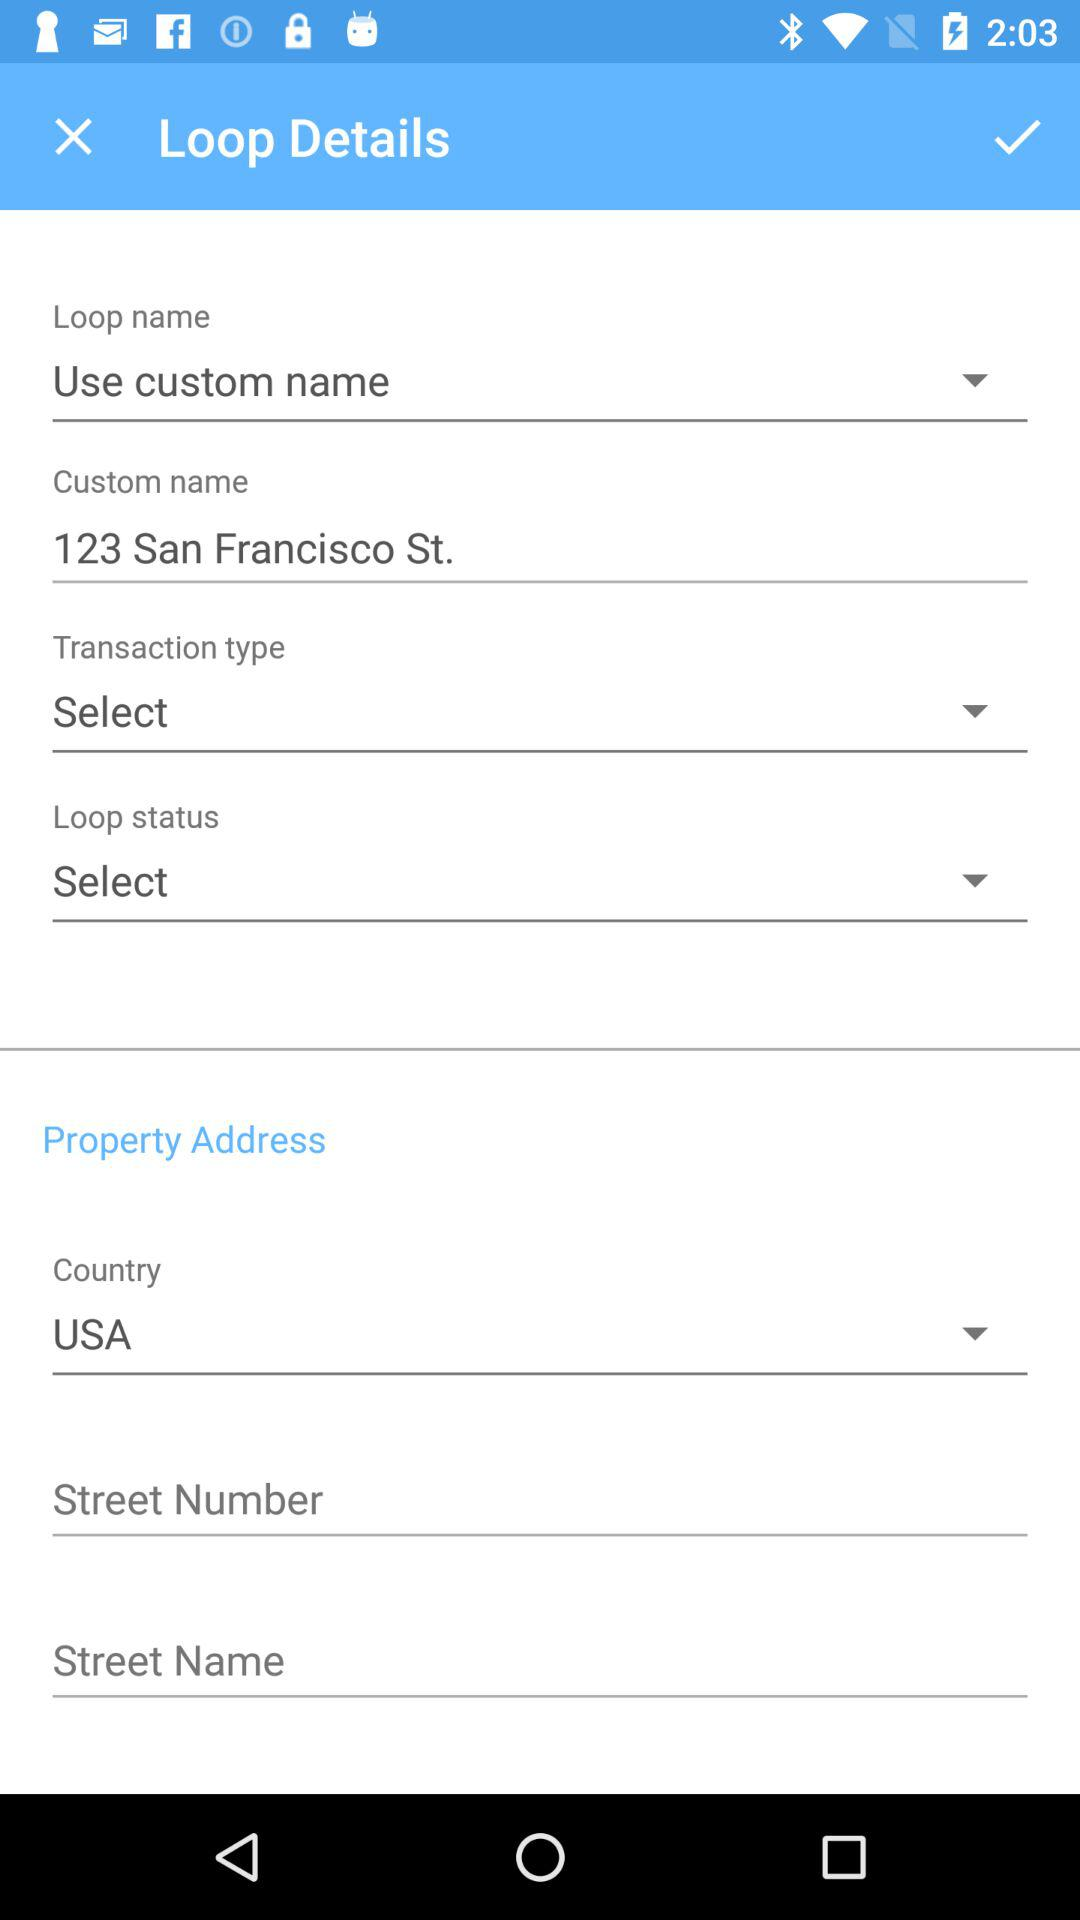Which country is selected? The selected country is the USA. 